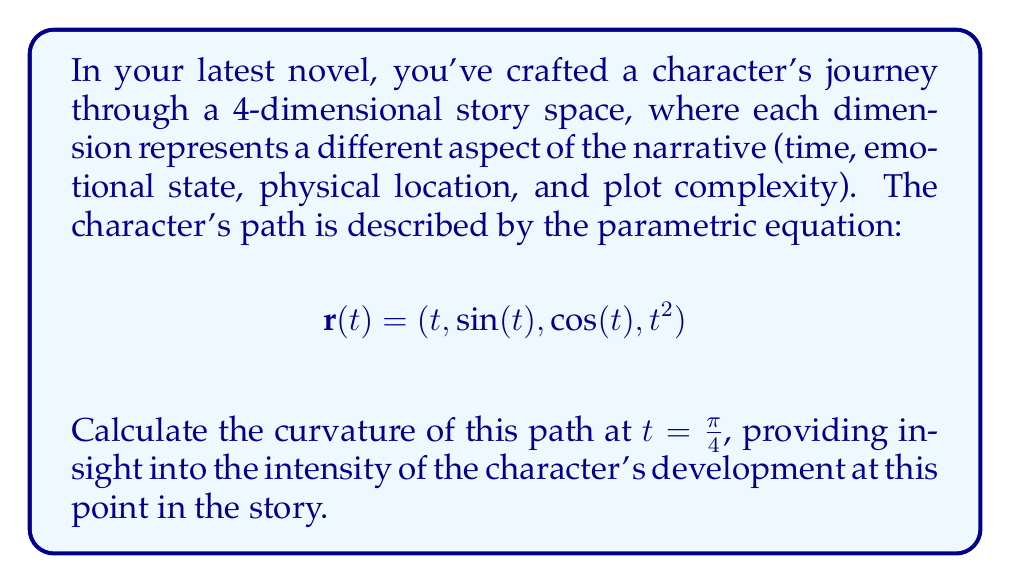Solve this math problem. To calculate the curvature of the character's journey, we'll use the formula for curvature in 4-dimensional space:

$$\kappa = \frac{\sqrt{|\mathbf{r}'(t) \times \mathbf{r}''(t) \times \mathbf{r}'''(t)|^2}}{|\mathbf{r}'(t)|^3}$$

Step 1: Calculate $\mathbf{r}'(t)$, $\mathbf{r}''(t)$, and $\mathbf{r}'''(t)$:
$$\mathbf{r}'(t) = (1, \cos(t), -\sin(t), 2t)$$
$$\mathbf{r}''(t) = (0, -\sin(t), -\cos(t), 2)$$
$$\mathbf{r}'''(t) = (0, -\cos(t), \sin(t), 0)$$

Step 2: Evaluate these at $t = \frac{\pi}{4}$:
$$\mathbf{r}'(\frac{\pi}{4}) = (1, \frac{\sqrt{2}}{2}, -\frac{\sqrt{2}}{2}, \frac{\pi}{2})$$
$$\mathbf{r}''(\frac{\pi}{4}) = (0, -\frac{\sqrt{2}}{2}, -\frac{\sqrt{2}}{2}, 2)$$
$$\mathbf{r}'''(\frac{\pi}{4}) = (0, -\frac{\sqrt{2}}{2}, \frac{\sqrt{2}}{2}, 0)$$

Step 3: Calculate the triple cross product $\mathbf{r}'(\frac{\pi}{4}) \times \mathbf{r}''(\frac{\pi}{4}) \times \mathbf{r}'''(\frac{\pi}{4})$:
This can be done using the 4D determinant method. The result is:
$$(2\sqrt{2}, -\frac{\pi\sqrt{2}}{2}, -\frac{\pi\sqrt{2}}{2}, -2)$$

Step 4: Calculate $|\mathbf{r}'(\frac{\pi}{4}) \times \mathbf{r}''(\frac{\pi}{4}) \times \mathbf{r}'''(\frac{\pi}{4})|^2$:
$$8 + \frac{\pi^2}{2} + \frac{\pi^2}{2} + 4 = 12 + \pi^2$$

Step 5: Calculate $|\mathbf{r}'(\frac{\pi}{4})|^3$:
$$\left(1 + \frac{1}{2} + \frac{1}{2} + \frac{\pi^2}{4}\right)^{\frac{3}{2}} = \left(2 + \frac{\pi^2}{4}\right)^{\frac{3}{2}}$$

Step 6: Apply the curvature formula:
$$\kappa = \frac{\sqrt{12 + \pi^2}}{\left(2 + \frac{\pi^2}{4}\right)^{\frac{3}{2}}}$$
Answer: $$\kappa = \frac{\sqrt{12 + \pi^2}}{\left(2 + \frac{\pi^2}{4}\right)^{\frac{3}{2}}}$$ 